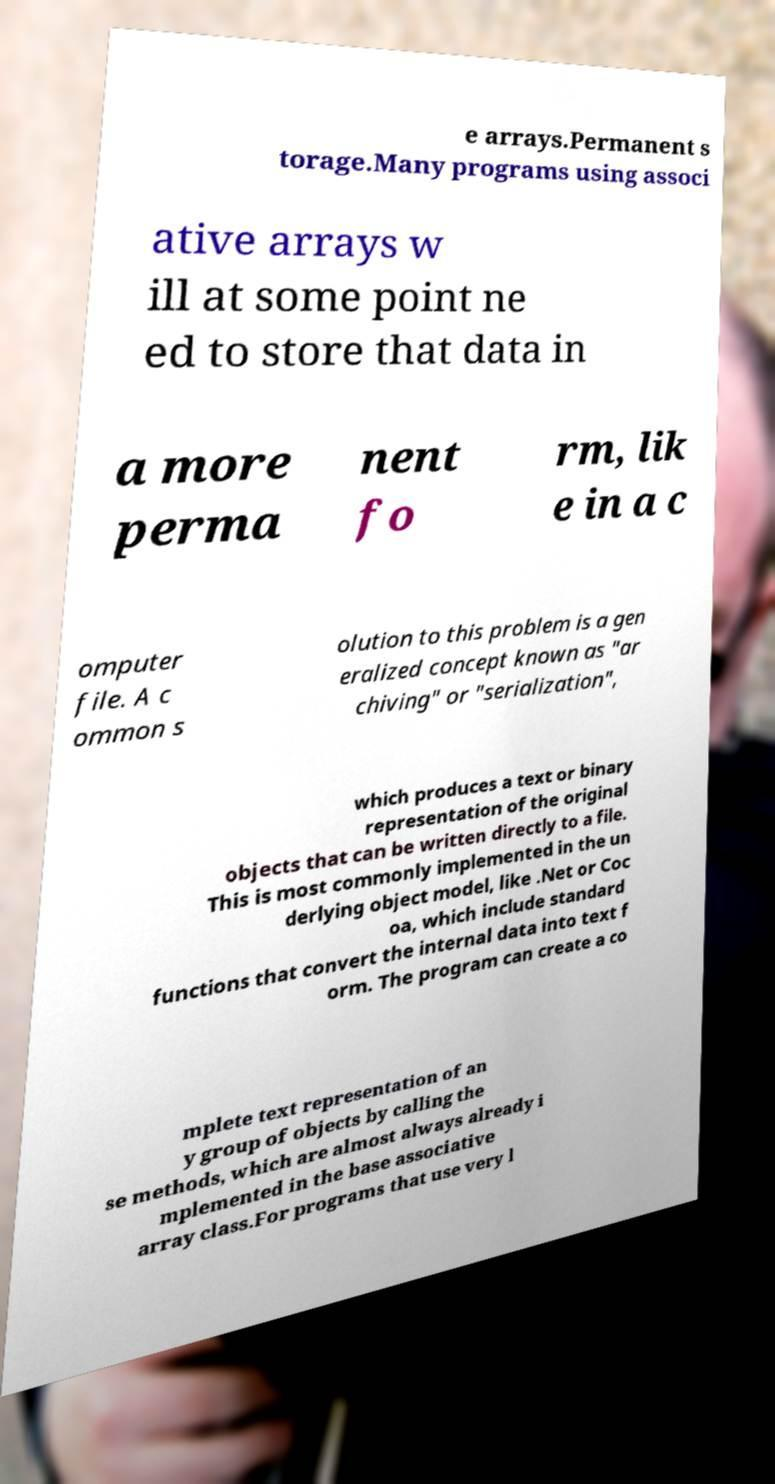Could you extract and type out the text from this image? e arrays.Permanent s torage.Many programs using associ ative arrays w ill at some point ne ed to store that data in a more perma nent fo rm, lik e in a c omputer file. A c ommon s olution to this problem is a gen eralized concept known as "ar chiving" or "serialization", which produces a text or binary representation of the original objects that can be written directly to a file. This is most commonly implemented in the un derlying object model, like .Net or Coc oa, which include standard functions that convert the internal data into text f orm. The program can create a co mplete text representation of an y group of objects by calling the se methods, which are almost always already i mplemented in the base associative array class.For programs that use very l 